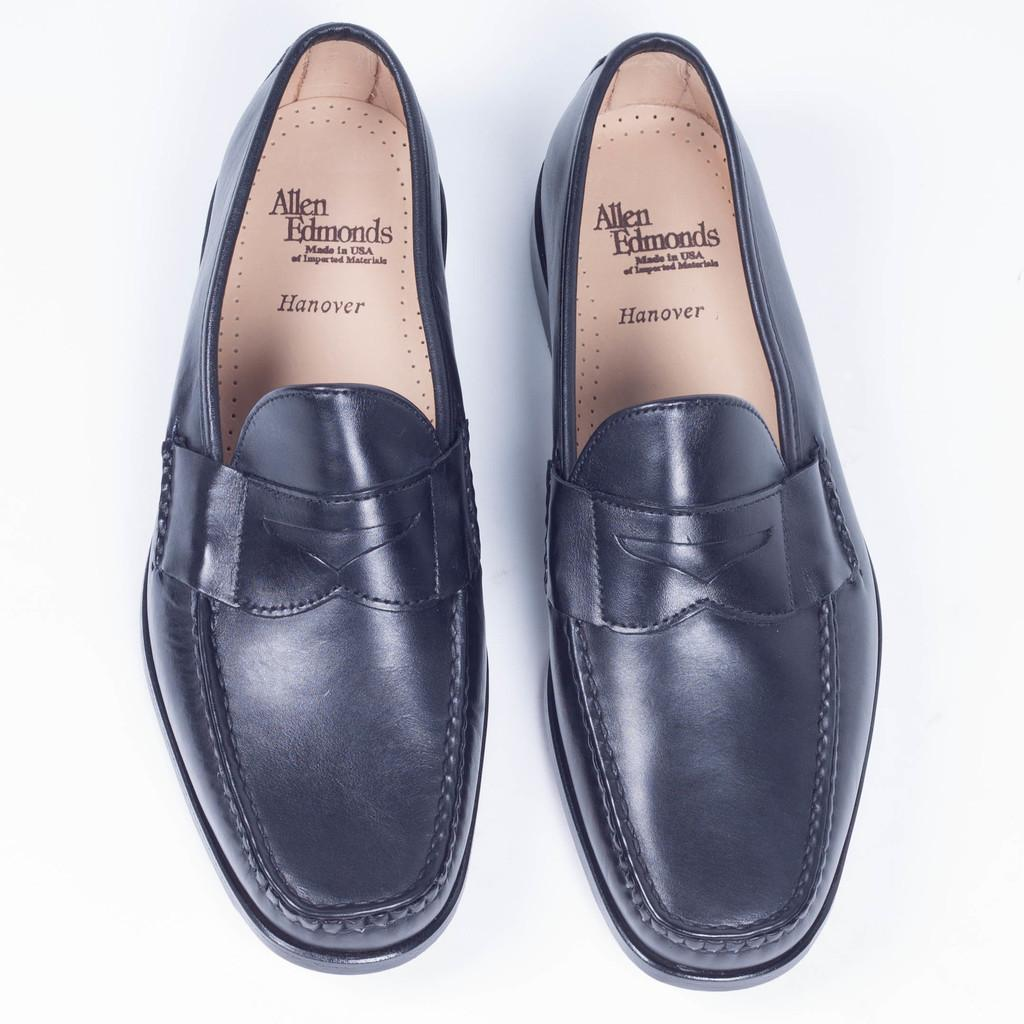What type of footwear is present in the image? There are shoes in the image. What colors can be seen on the shoes? The shoes are black and brown in color. What is the color of the surface on which the shoes are placed? The shoes are on a white surface. What type of sweater is being worn by the bears in the image? There are no bears or sweaters present in the image; it only features shoes on a white surface. 